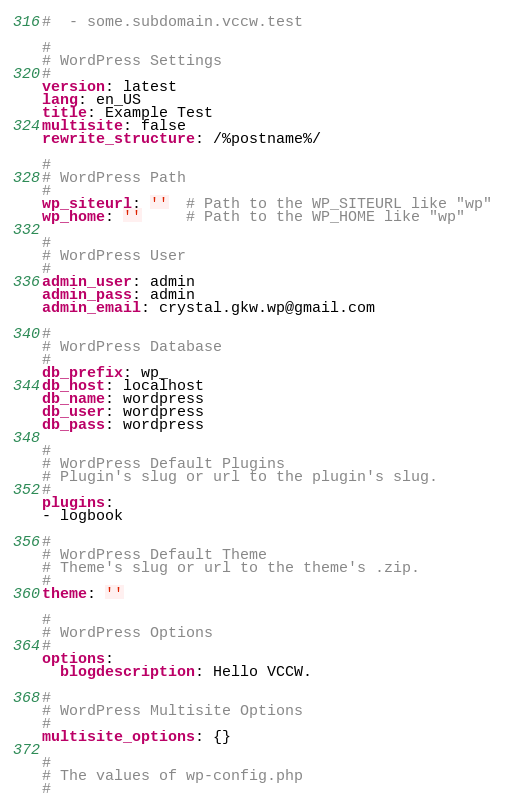Convert code to text. <code><loc_0><loc_0><loc_500><loc_500><_YAML_>#  - some.subdomain.vccw.test

#
# WordPress Settings
#
version: latest
lang: en_US
title: Example Test
multisite: false
rewrite_structure: /%postname%/

#
# WordPress Path
#
wp_siteurl: ''  # Path to the WP_SITEURL like "wp"
wp_home: ''     # Path to the WP_HOME like "wp"

#
# WordPress User
#
admin_user: admin
admin_pass: admin
admin_email: crystal.gkw.wp@gmail.com

#
# WordPress Database
#
db_prefix: wp_
db_host: localhost
db_name: wordpress
db_user: wordpress
db_pass: wordpress

#
# WordPress Default Plugins
# Plugin's slug or url to the plugin's slug.
#
plugins:
- logbook

#
# WordPress Default Theme
# Theme's slug or url to the theme's .zip.
#
theme: ''

#
# WordPress Options
#
options:
  blogdescription: Hello VCCW.

#
# WordPress Multisite Options
#
multisite_options: {}

#
# The values of wp-config.php
#</code> 